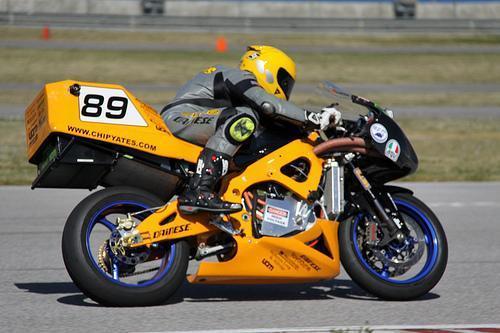How many people are shown?
Give a very brief answer. 1. 